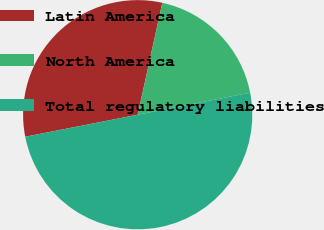Convert chart to OTSL. <chart><loc_0><loc_0><loc_500><loc_500><pie_chart><fcel>Latin America<fcel>North America<fcel>Total regulatory liabilities<nl><fcel>31.52%<fcel>18.48%<fcel>50.0%<nl></chart> 